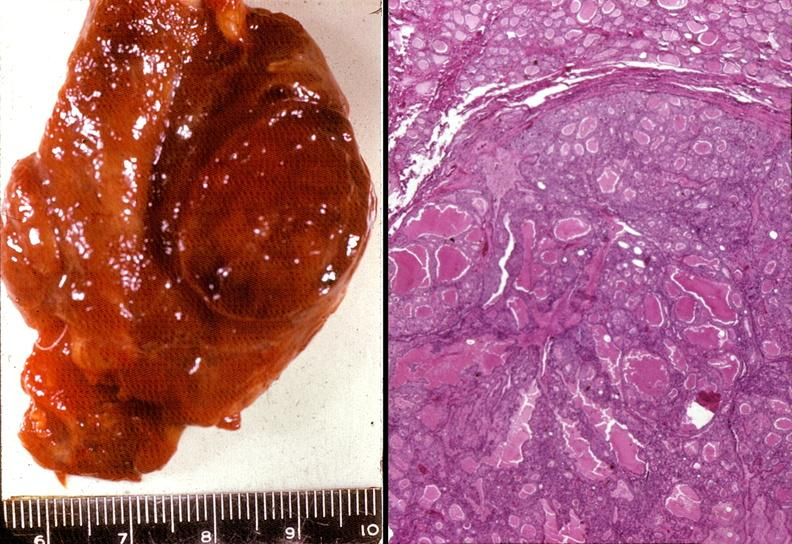does this image show thyroid, follicular adenoma?
Answer the question using a single word or phrase. Yes 